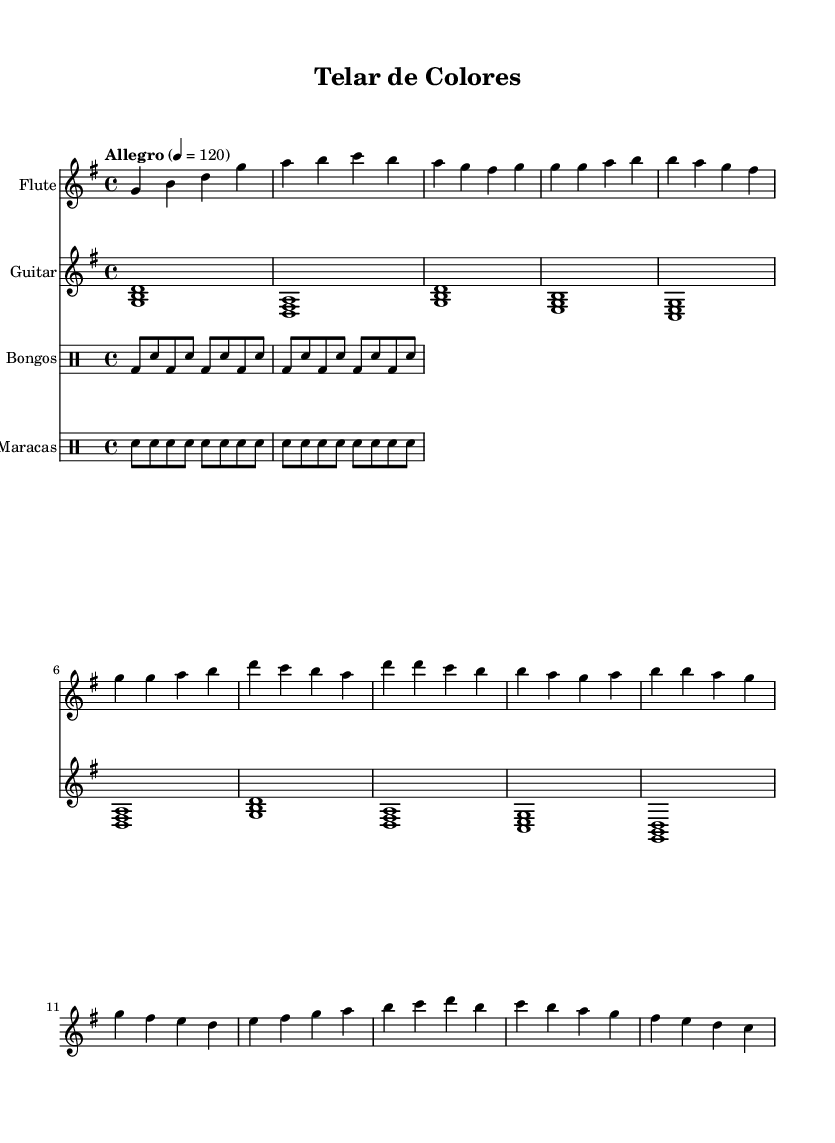What is the key signature of this music? The key signature is G major, which has one sharp (F#). This can be determined by looking at the beginning of the staff where the sharps are indicated.
Answer: G major What is the time signature of this piece? The time signature is 4/4, which is seen at the beginning of the score. This indicates that there are four beats per measure and the quarter note gets one beat.
Answer: 4/4 What is the tempo marking of the music? The tempo marking is "Allegro," indicated near the beginning of the score. This term means a brisk and lively tempo, typically around 120 beats per minute, as also noted in the score.
Answer: Allegro How many staves are used in this score? There are four staves used in this score, one for each instrument: flute, guitar, bongos, and maracas. This can be counted by looking at the layout of the score.
Answer: Four What type of percussion instruments are featured in this piece? The percussion instruments featured in this piece are bongos and maracas, as indicated in the staff labels for their respective parts.
Answer: Bongos and maracas What is the first note played by the flute? The first note played by the flute is G, as shown in the first measure of the flute part. This is located above the staff where the notes are written.
Answer: G Which musical texture is suggested by the arrangement of instruments? The texture suggested is polyphonic, as there are multiple independent melodic lines in the flute and guitar parts along with rhythmic support from the percussion. This can be inferred from the presence of different instruments playing different lines simultaneously.
Answer: Polyphonic 